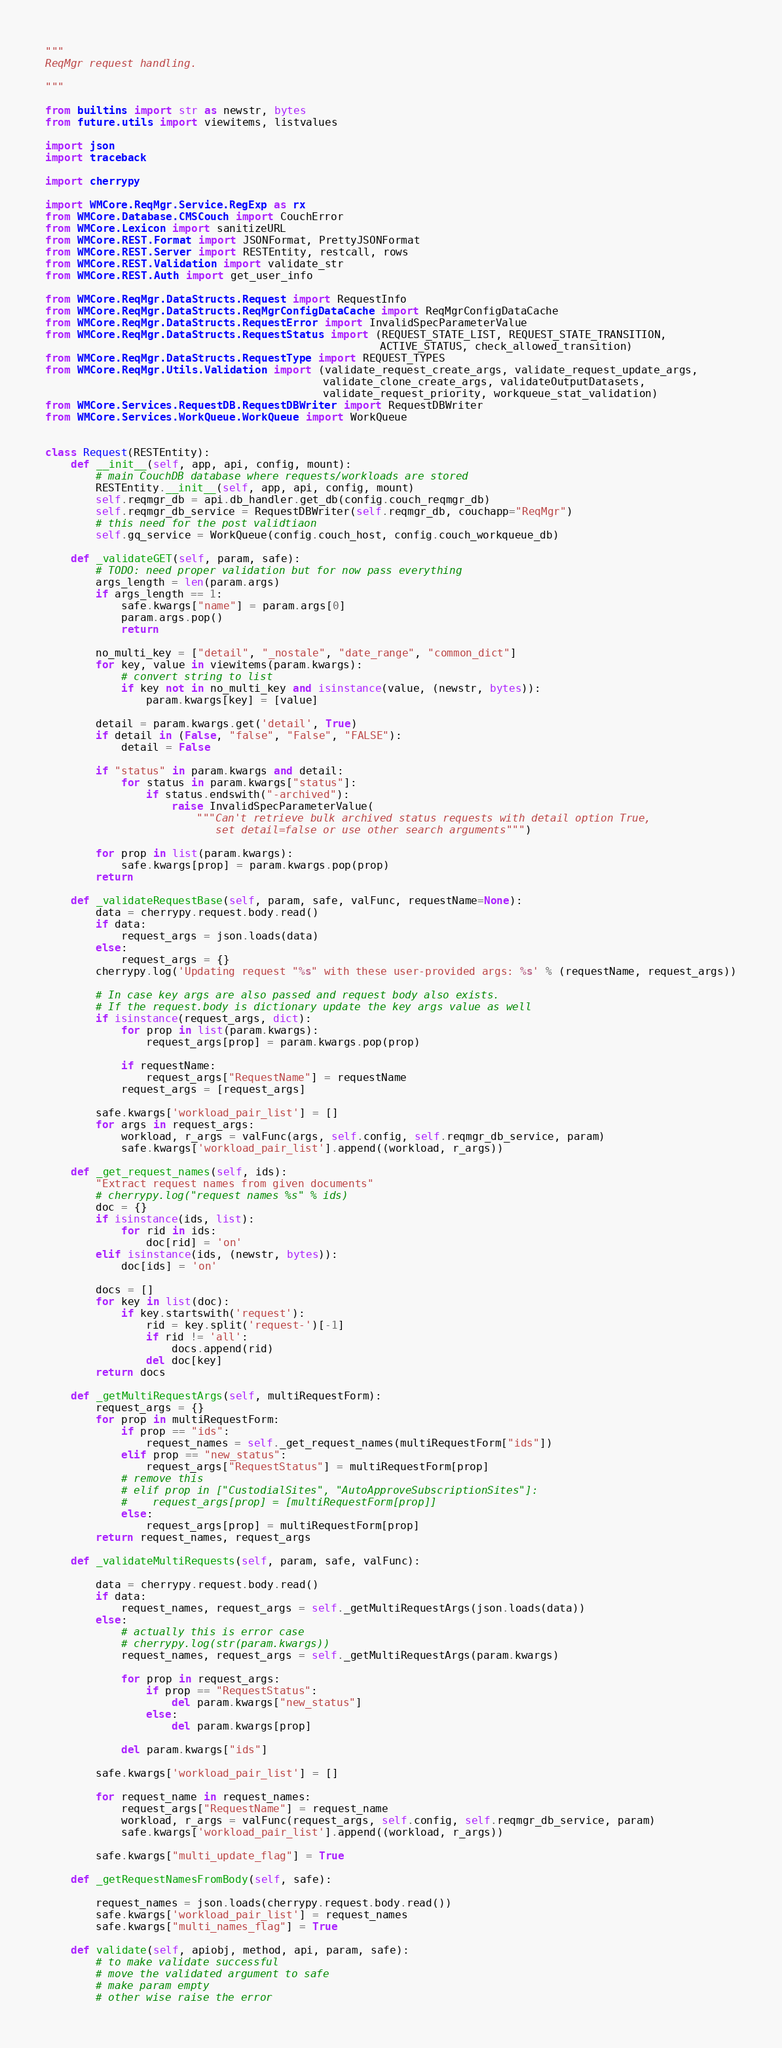Convert code to text. <code><loc_0><loc_0><loc_500><loc_500><_Python_>"""
ReqMgr request handling.

"""

from builtins import str as newstr, bytes
from future.utils import viewitems, listvalues

import json
import traceback

import cherrypy

import WMCore.ReqMgr.Service.RegExp as rx
from WMCore.Database.CMSCouch import CouchError
from WMCore.Lexicon import sanitizeURL
from WMCore.REST.Format import JSONFormat, PrettyJSONFormat
from WMCore.REST.Server import RESTEntity, restcall, rows
from WMCore.REST.Validation import validate_str
from WMCore.REST.Auth import get_user_info

from WMCore.ReqMgr.DataStructs.Request import RequestInfo
from WMCore.ReqMgr.DataStructs.ReqMgrConfigDataCache import ReqMgrConfigDataCache
from WMCore.ReqMgr.DataStructs.RequestError import InvalidSpecParameterValue
from WMCore.ReqMgr.DataStructs.RequestStatus import (REQUEST_STATE_LIST, REQUEST_STATE_TRANSITION,
                                                     ACTIVE_STATUS, check_allowed_transition)
from WMCore.ReqMgr.DataStructs.RequestType import REQUEST_TYPES
from WMCore.ReqMgr.Utils.Validation import (validate_request_create_args, validate_request_update_args,
                                            validate_clone_create_args, validateOutputDatasets,
                                            validate_request_priority, workqueue_stat_validation)
from WMCore.Services.RequestDB.RequestDBWriter import RequestDBWriter
from WMCore.Services.WorkQueue.WorkQueue import WorkQueue


class Request(RESTEntity):
    def __init__(self, app, api, config, mount):
        # main CouchDB database where requests/workloads are stored
        RESTEntity.__init__(self, app, api, config, mount)
        self.reqmgr_db = api.db_handler.get_db(config.couch_reqmgr_db)
        self.reqmgr_db_service = RequestDBWriter(self.reqmgr_db, couchapp="ReqMgr")
        # this need for the post validtiaon
        self.gq_service = WorkQueue(config.couch_host, config.couch_workqueue_db)

    def _validateGET(self, param, safe):
        # TODO: need proper validation but for now pass everything
        args_length = len(param.args)
        if args_length == 1:
            safe.kwargs["name"] = param.args[0]
            param.args.pop()
            return

        no_multi_key = ["detail", "_nostale", "date_range", "common_dict"]
        for key, value in viewitems(param.kwargs):
            # convert string to list
            if key not in no_multi_key and isinstance(value, (newstr, bytes)):
                param.kwargs[key] = [value]

        detail = param.kwargs.get('detail', True)
        if detail in (False, "false", "False", "FALSE"):
            detail = False

        if "status" in param.kwargs and detail:
            for status in param.kwargs["status"]:
                if status.endswith("-archived"):
                    raise InvalidSpecParameterValue(
                        """Can't retrieve bulk archived status requests with detail option True,
                           set detail=false or use other search arguments""")

        for prop in list(param.kwargs):
            safe.kwargs[prop] = param.kwargs.pop(prop)
        return

    def _validateRequestBase(self, param, safe, valFunc, requestName=None):
        data = cherrypy.request.body.read()
        if data:
            request_args = json.loads(data)
        else:
            request_args = {}
        cherrypy.log('Updating request "%s" with these user-provided args: %s' % (requestName, request_args))

        # In case key args are also passed and request body also exists.
        # If the request.body is dictionary update the key args value as well
        if isinstance(request_args, dict):
            for prop in list(param.kwargs):
                request_args[prop] = param.kwargs.pop(prop)

            if requestName:
                request_args["RequestName"] = requestName
            request_args = [request_args]

        safe.kwargs['workload_pair_list'] = []
        for args in request_args:
            workload, r_args = valFunc(args, self.config, self.reqmgr_db_service, param)
            safe.kwargs['workload_pair_list'].append((workload, r_args))

    def _get_request_names(self, ids):
        "Extract request names from given documents"
        # cherrypy.log("request names %s" % ids)
        doc = {}
        if isinstance(ids, list):
            for rid in ids:
                doc[rid] = 'on'
        elif isinstance(ids, (newstr, bytes)):
            doc[ids] = 'on'

        docs = []
        for key in list(doc):
            if key.startswith('request'):
                rid = key.split('request-')[-1]
                if rid != 'all':
                    docs.append(rid)
                del doc[key]
        return docs

    def _getMultiRequestArgs(self, multiRequestForm):
        request_args = {}
        for prop in multiRequestForm:
            if prop == "ids":
                request_names = self._get_request_names(multiRequestForm["ids"])
            elif prop == "new_status":
                request_args["RequestStatus"] = multiRequestForm[prop]
            # remove this
            # elif prop in ["CustodialSites", "AutoApproveSubscriptionSites"]:
            #    request_args[prop] = [multiRequestForm[prop]]
            else:
                request_args[prop] = multiRequestForm[prop]
        return request_names, request_args

    def _validateMultiRequests(self, param, safe, valFunc):

        data = cherrypy.request.body.read()
        if data:
            request_names, request_args = self._getMultiRequestArgs(json.loads(data))
        else:
            # actually this is error case
            # cherrypy.log(str(param.kwargs))
            request_names, request_args = self._getMultiRequestArgs(param.kwargs)

            for prop in request_args:
                if prop == "RequestStatus":
                    del param.kwargs["new_status"]
                else:
                    del param.kwargs[prop]

            del param.kwargs["ids"]

        safe.kwargs['workload_pair_list'] = []

        for request_name in request_names:
            request_args["RequestName"] = request_name
            workload, r_args = valFunc(request_args, self.config, self.reqmgr_db_service, param)
            safe.kwargs['workload_pair_list'].append((workload, r_args))

        safe.kwargs["multi_update_flag"] = True

    def _getRequestNamesFromBody(self, safe):

        request_names = json.loads(cherrypy.request.body.read())
        safe.kwargs['workload_pair_list'] = request_names
        safe.kwargs["multi_names_flag"] = True

    def validate(self, apiobj, method, api, param, safe):
        # to make validate successful
        # move the validated argument to safe
        # make param empty
        # other wise raise the error</code> 